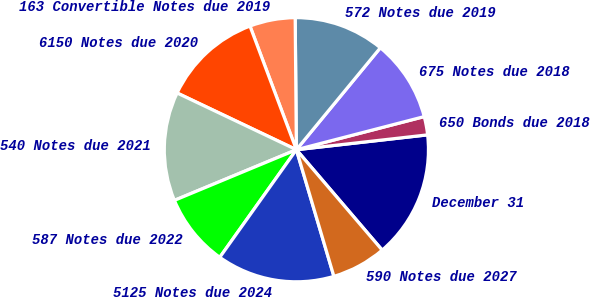Convert chart. <chart><loc_0><loc_0><loc_500><loc_500><pie_chart><fcel>December 31<fcel>650 Bonds due 2018<fcel>675 Notes due 2018<fcel>572 Notes due 2019<fcel>163 Convertible Notes due 2019<fcel>6150 Notes due 2020<fcel>540 Notes due 2021<fcel>587 Notes due 2022<fcel>5125 Notes due 2024<fcel>590 Notes due 2027<nl><fcel>15.54%<fcel>2.24%<fcel>10.0%<fcel>11.11%<fcel>5.57%<fcel>12.22%<fcel>13.33%<fcel>8.89%<fcel>14.43%<fcel>6.67%<nl></chart> 